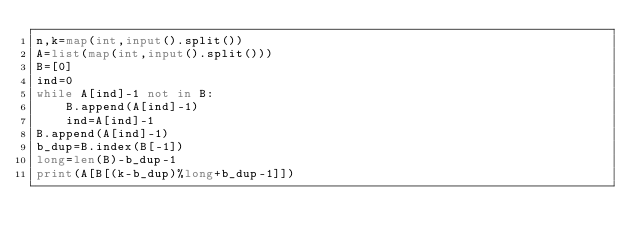Convert code to text. <code><loc_0><loc_0><loc_500><loc_500><_Python_>n,k=map(int,input().split())
A=list(map(int,input().split()))
B=[0]
ind=0
while A[ind]-1 not in B:
    B.append(A[ind]-1)
    ind=A[ind]-1
B.append(A[ind]-1)
b_dup=B.index(B[-1])
long=len(B)-b_dup-1
print(A[B[(k-b_dup)%long+b_dup-1]])</code> 